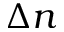Convert formula to latex. <formula><loc_0><loc_0><loc_500><loc_500>\Delta n</formula> 